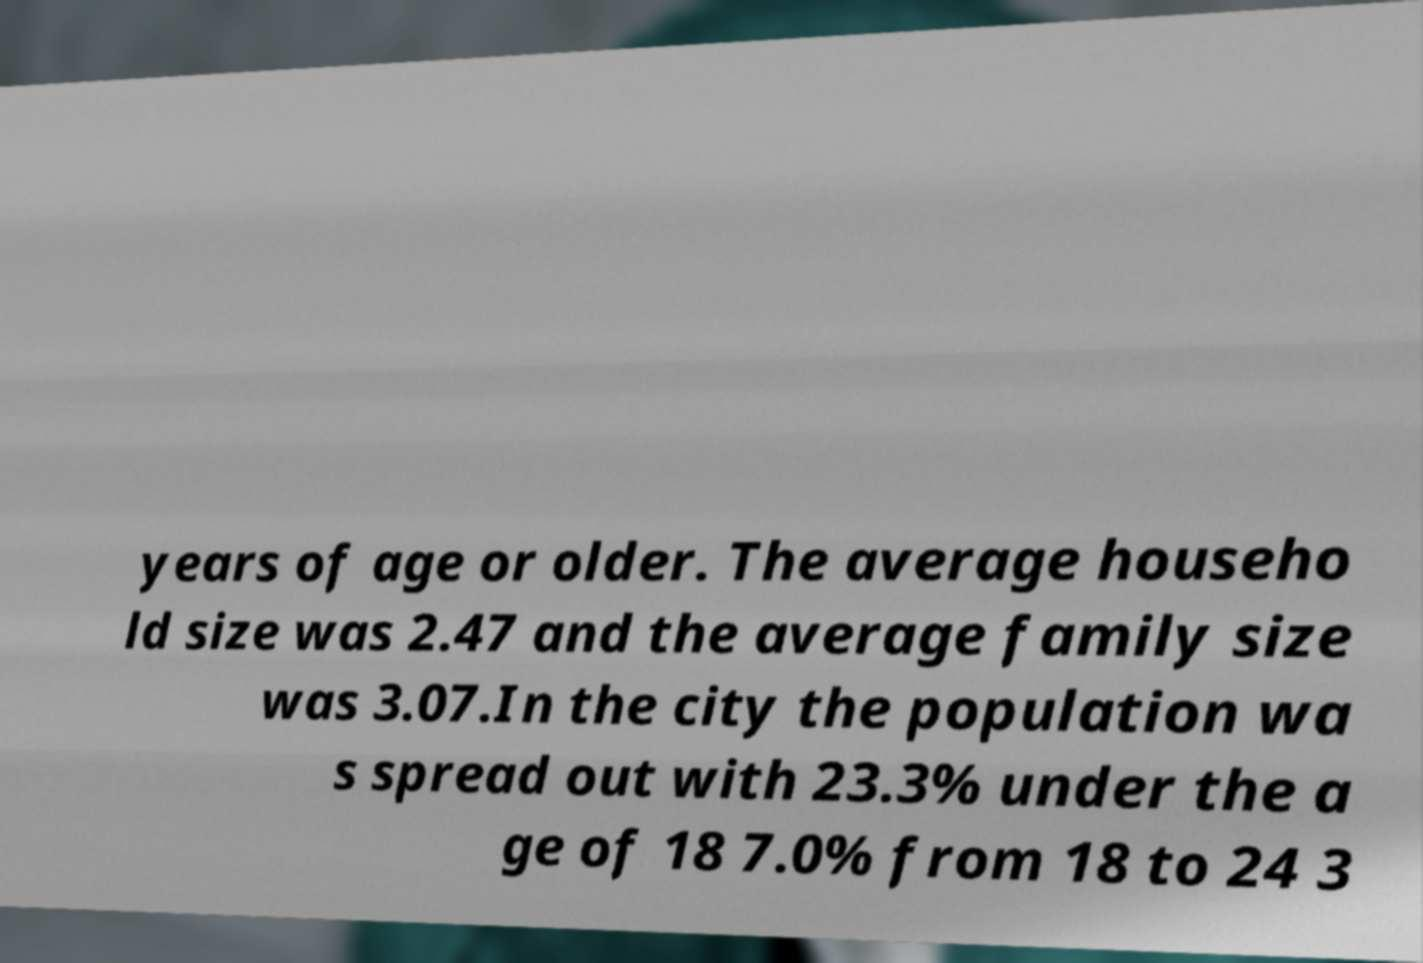Please read and relay the text visible in this image. What does it say? years of age or older. The average househo ld size was 2.47 and the average family size was 3.07.In the city the population wa s spread out with 23.3% under the a ge of 18 7.0% from 18 to 24 3 